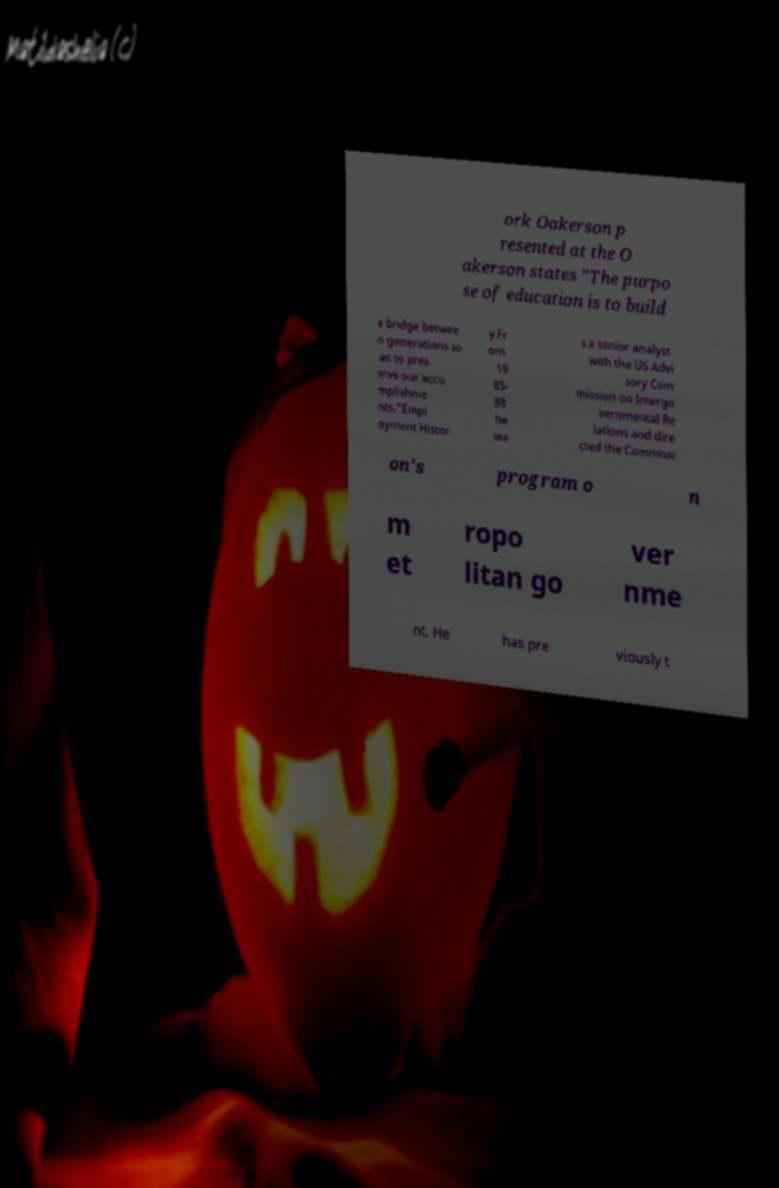Can you read and provide the text displayed in the image?This photo seems to have some interesting text. Can you extract and type it out for me? ork Oakerson p resented at the O akerson states "The purpo se of education is to build a bridge betwee n generations so as to pres erve our acco mplishme nts."Empl oyment Histor y.Fr om 19 85- 88 he wa s a senior analyst with the US Advi sory Com mission on Intergo vernmental Re lations and dire cted the Commissi on's program o n m et ropo litan go ver nme nt. He has pre viously t 